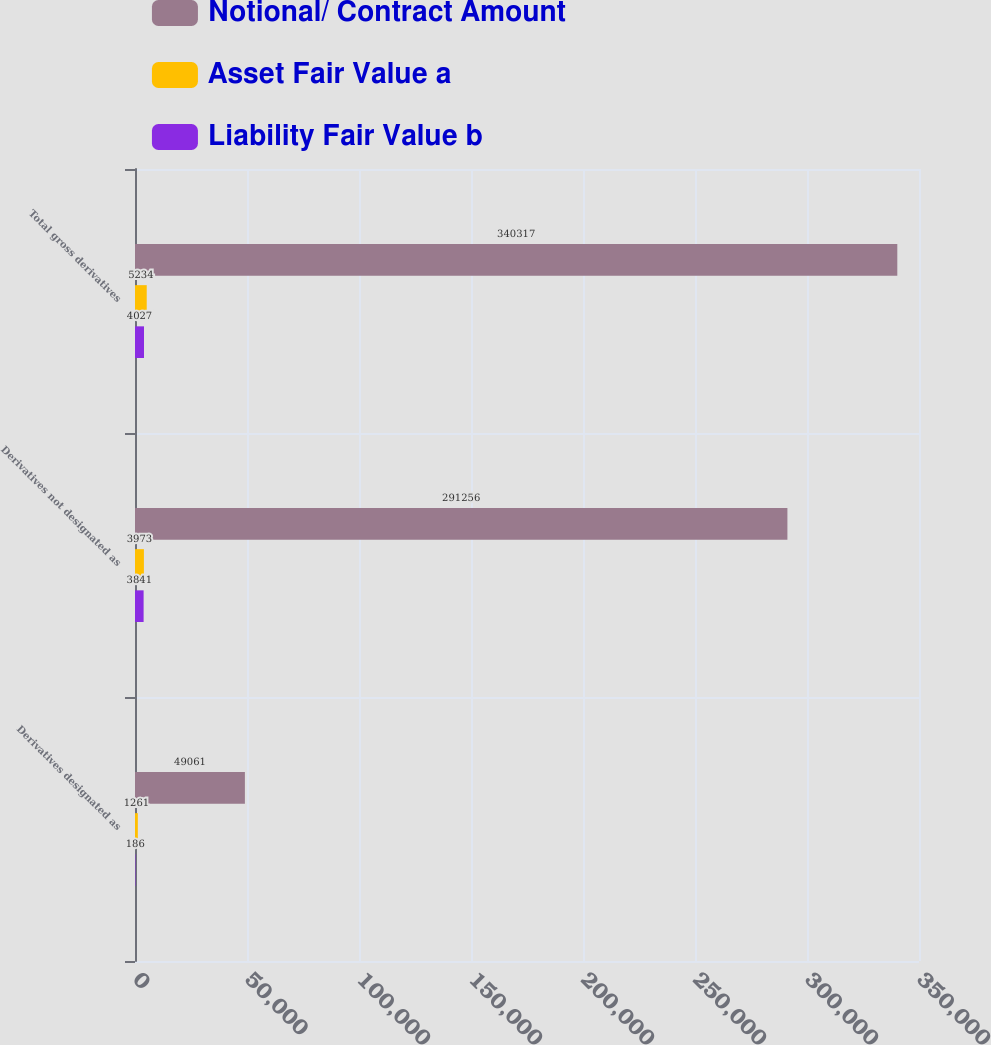Convert chart to OTSL. <chart><loc_0><loc_0><loc_500><loc_500><stacked_bar_chart><ecel><fcel>Derivatives designated as<fcel>Derivatives not designated as<fcel>Total gross derivatives<nl><fcel>Notional/ Contract Amount<fcel>49061<fcel>291256<fcel>340317<nl><fcel>Asset Fair Value a<fcel>1261<fcel>3973<fcel>5234<nl><fcel>Liability Fair Value b<fcel>186<fcel>3841<fcel>4027<nl></chart> 